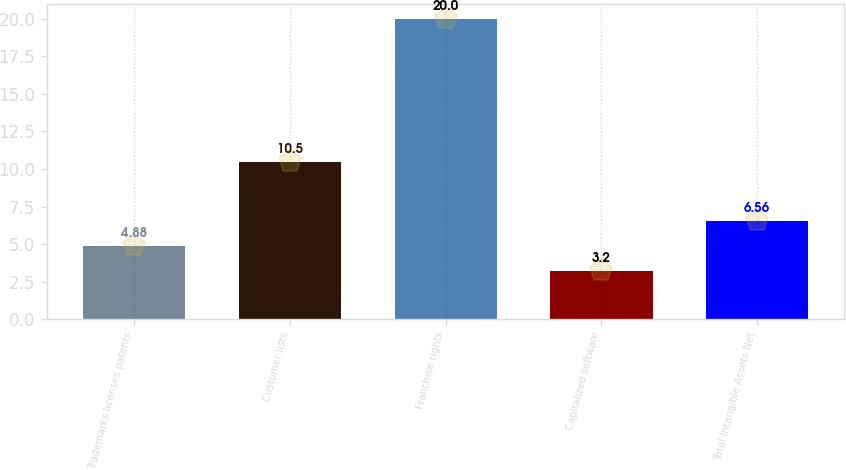Convert chart. <chart><loc_0><loc_0><loc_500><loc_500><bar_chart><fcel>Trademarks licenses patents<fcel>Customer lists<fcel>Franchise rights<fcel>Capitalized software<fcel>Total Intangible Assets Net<nl><fcel>4.88<fcel>10.5<fcel>20<fcel>3.2<fcel>6.56<nl></chart> 